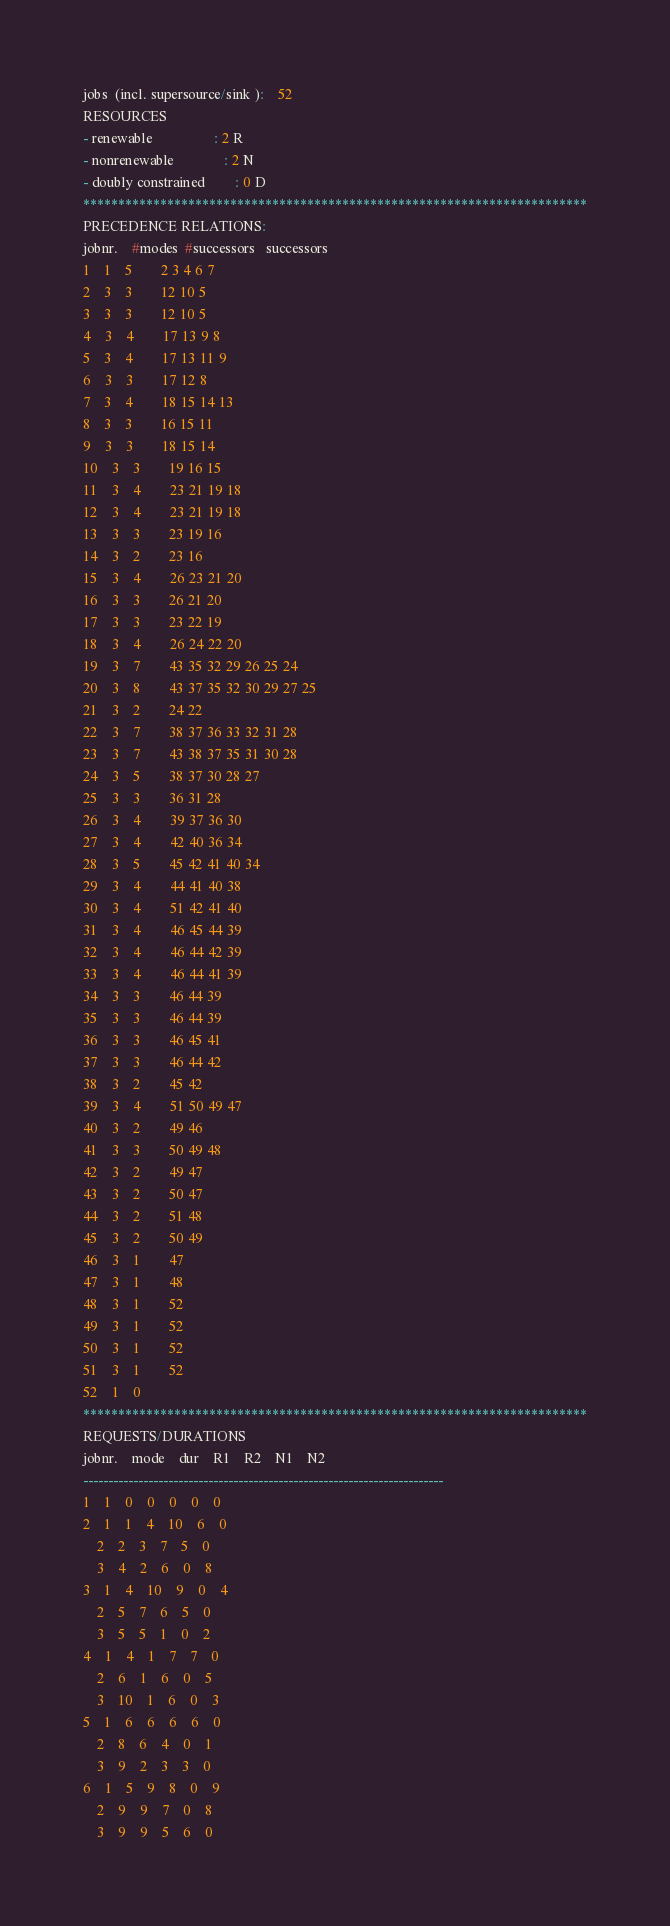Convert code to text. <code><loc_0><loc_0><loc_500><loc_500><_ObjectiveC_>jobs  (incl. supersource/sink ):	52
RESOURCES
- renewable                 : 2 R
- nonrenewable              : 2 N
- doubly constrained        : 0 D
************************************************************************
PRECEDENCE RELATIONS:
jobnr.    #modes  #successors   successors
1	1	5		2 3 4 6 7 
2	3	3		12 10 5 
3	3	3		12 10 5 
4	3	4		17 13 9 8 
5	3	4		17 13 11 9 
6	3	3		17 12 8 
7	3	4		18 15 14 13 
8	3	3		16 15 11 
9	3	3		18 15 14 
10	3	3		19 16 15 
11	3	4		23 21 19 18 
12	3	4		23 21 19 18 
13	3	3		23 19 16 
14	3	2		23 16 
15	3	4		26 23 21 20 
16	3	3		26 21 20 
17	3	3		23 22 19 
18	3	4		26 24 22 20 
19	3	7		43 35 32 29 26 25 24 
20	3	8		43 37 35 32 30 29 27 25 
21	3	2		24 22 
22	3	7		38 37 36 33 32 31 28 
23	3	7		43 38 37 35 31 30 28 
24	3	5		38 37 30 28 27 
25	3	3		36 31 28 
26	3	4		39 37 36 30 
27	3	4		42 40 36 34 
28	3	5		45 42 41 40 34 
29	3	4		44 41 40 38 
30	3	4		51 42 41 40 
31	3	4		46 45 44 39 
32	3	4		46 44 42 39 
33	3	4		46 44 41 39 
34	3	3		46 44 39 
35	3	3		46 44 39 
36	3	3		46 45 41 
37	3	3		46 44 42 
38	3	2		45 42 
39	3	4		51 50 49 47 
40	3	2		49 46 
41	3	3		50 49 48 
42	3	2		49 47 
43	3	2		50 47 
44	3	2		51 48 
45	3	2		50 49 
46	3	1		47 
47	3	1		48 
48	3	1		52 
49	3	1		52 
50	3	1		52 
51	3	1		52 
52	1	0		
************************************************************************
REQUESTS/DURATIONS
jobnr.	mode	dur	R1	R2	N1	N2	
------------------------------------------------------------------------
1	1	0	0	0	0	0	
2	1	1	4	10	6	0	
	2	2	3	7	5	0	
	3	4	2	6	0	8	
3	1	4	10	9	0	4	
	2	5	7	6	5	0	
	3	5	5	1	0	2	
4	1	4	1	7	7	0	
	2	6	1	6	0	5	
	3	10	1	6	0	3	
5	1	6	6	6	6	0	
	2	8	6	4	0	1	
	3	9	2	3	3	0	
6	1	5	9	8	0	9	
	2	9	9	7	0	8	
	3	9	9	5	6	0	</code> 